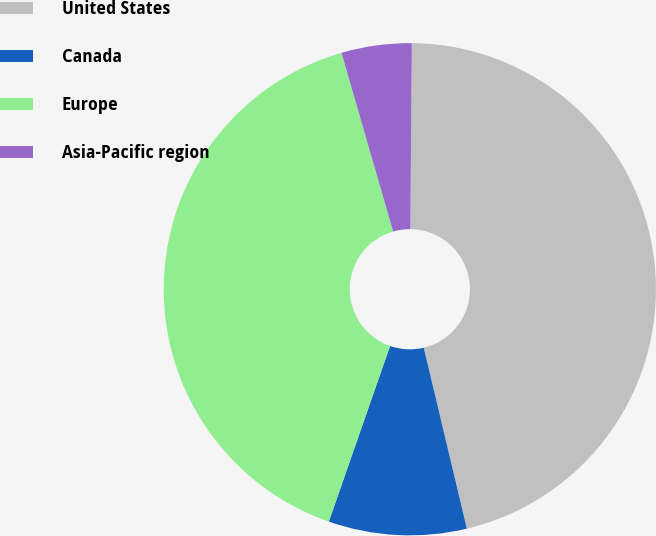<chart> <loc_0><loc_0><loc_500><loc_500><pie_chart><fcel>United States<fcel>Canada<fcel>Europe<fcel>Asia-Pacific region<nl><fcel>46.15%<fcel>9.06%<fcel>40.18%<fcel>4.61%<nl></chart> 